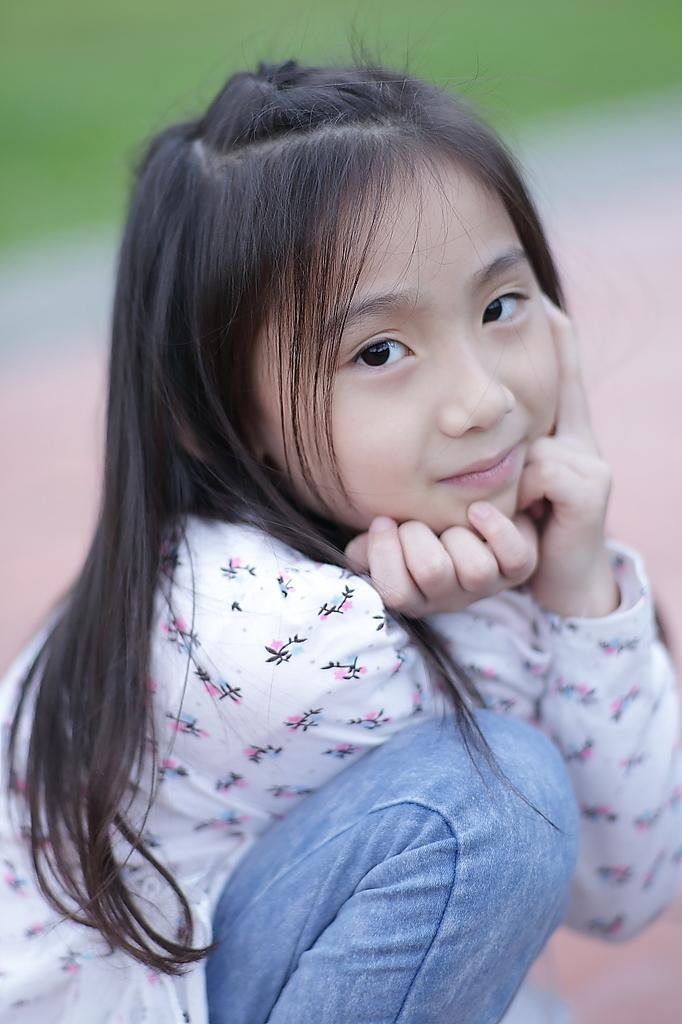Who is the main subject in the picture? There is a girl in the picture. Can you describe the background of the image? The background of the picture is blurry. What type of haircut does the girl have in the picture? There is no information about the girl's haircut in the image. What class is the girl attending in the picture? There is no indication of a class or educational setting in the image. 